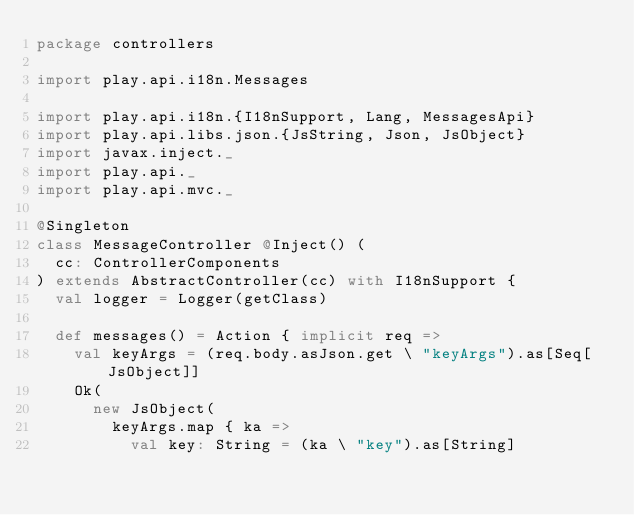Convert code to text. <code><loc_0><loc_0><loc_500><loc_500><_Scala_>package controllers

import play.api.i18n.Messages

import play.api.i18n.{I18nSupport, Lang, MessagesApi}
import play.api.libs.json.{JsString, Json, JsObject}
import javax.inject._
import play.api._
import play.api.mvc._

@Singleton
class MessageController @Inject() (
  cc: ControllerComponents
) extends AbstractController(cc) with I18nSupport {
  val logger = Logger(getClass)

  def messages() = Action { implicit req =>
    val keyArgs = (req.body.asJson.get \ "keyArgs").as[Seq[JsObject]]
    Ok(
      new JsObject(
        keyArgs.map { ka =>
          val key: String = (ka \ "key").as[String]</code> 